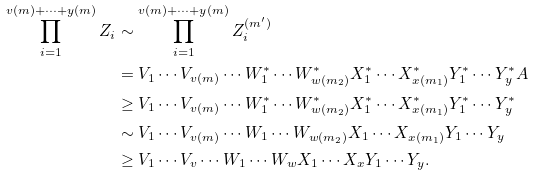<formula> <loc_0><loc_0><loc_500><loc_500>\prod _ { i = 1 } ^ { v ( m ) + \cdots + y ( m ) } Z _ { i } & \sim \prod _ { i = 1 } ^ { v ( m ) + \cdots + y ( m ) } Z ^ { ( m ^ { \prime } ) } _ { i } \\ & = V _ { 1 } \cdots V _ { v ( m ) } \cdots W ^ { * } _ { 1 } \cdots W ^ { * } _ { w ( m _ { 2 } ) } X ^ { * } _ { 1 } \cdots X ^ { * } _ { x ( m _ { 1 } ) } Y _ { 1 } ^ { * } \cdots Y _ { y } ^ { * } A \\ & \geq V _ { 1 } \cdots V _ { v ( m ) } \cdots W ^ { * } _ { 1 } \cdots W ^ { * } _ { w ( m _ { 2 } ) } X ^ { * } _ { 1 } \cdots X ^ { * } _ { x ( m _ { 1 } ) } Y _ { 1 } ^ { * } \cdots Y _ { y } ^ { * } \\ & \sim V _ { 1 } \cdots V _ { v ( m ) } \cdots W _ { 1 } \cdots W _ { w ( m _ { 2 } ) } X _ { 1 } \cdots X _ { x ( m _ { 1 } ) } Y _ { 1 } \cdots Y _ { y } \\ & \geq V _ { 1 } \cdots V _ { v } \cdots W _ { 1 } \cdots W _ { w } X _ { 1 } \cdots X _ { x } Y _ { 1 } \cdots Y _ { y } .</formula> 